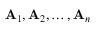Convert formula to latex. <formula><loc_0><loc_0><loc_500><loc_500>A _ { 1 } , A _ { 2 } , \dots , A _ { n }</formula> 